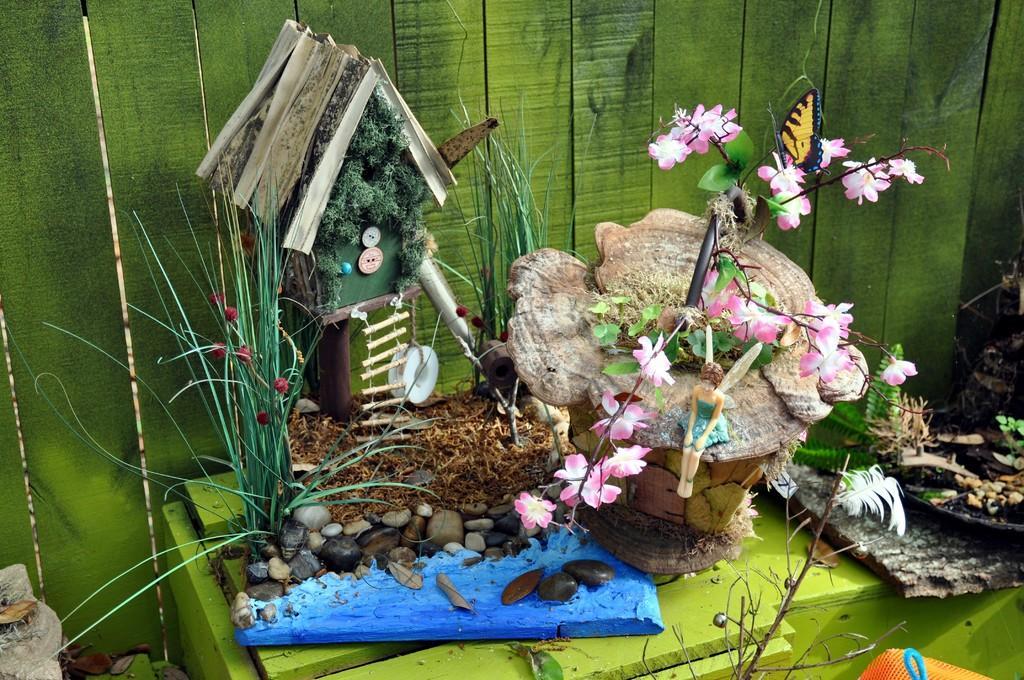How would you summarize this image in a sentence or two? In this image we can see showpiece is kept on the green color table. In the background, we can see green color wooden wall. Here we can see some plants, toys and butterfly. 